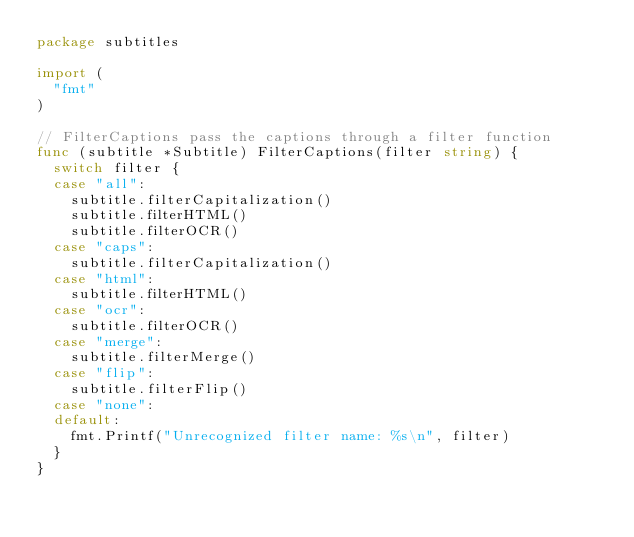<code> <loc_0><loc_0><loc_500><loc_500><_Go_>package subtitles

import (
	"fmt"
)

// FilterCaptions pass the captions through a filter function
func (subtitle *Subtitle) FilterCaptions(filter string) {
	switch filter {
	case "all":
		subtitle.filterCapitalization()
		subtitle.filterHTML()
		subtitle.filterOCR()
	case "caps":
		subtitle.filterCapitalization()
	case "html":
		subtitle.filterHTML()
	case "ocr":
		subtitle.filterOCR()
	case "merge":
		subtitle.filterMerge()
	case "flip":
		subtitle.filterFlip()
	case "none":
	default:
		fmt.Printf("Unrecognized filter name: %s\n", filter)
	}
}
</code> 